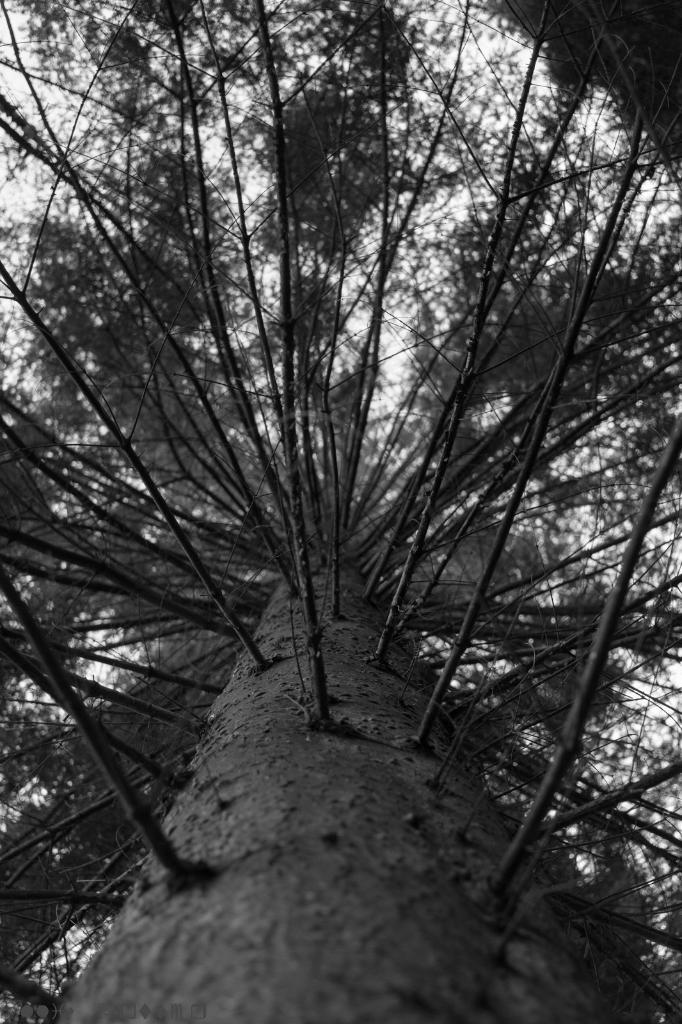What type of plant can be seen in the image? There is a tree in the image. What type of amusement is available for the tree in the image? There is no amusement available for the tree in the image, as it is a static object. Is the tree in the image sleeping? Trees do not sleep, so this question is not applicable to the image. 